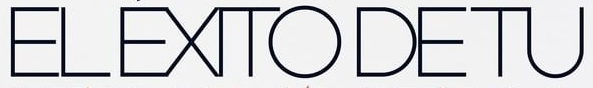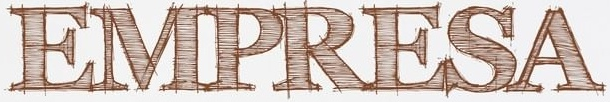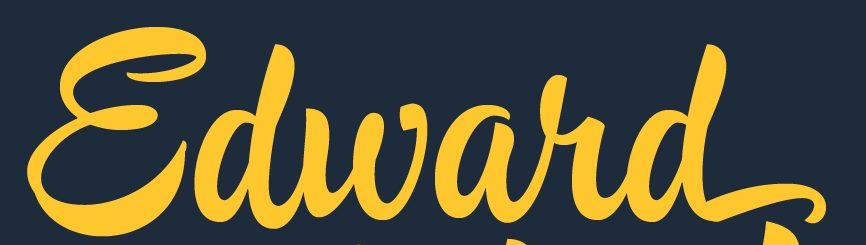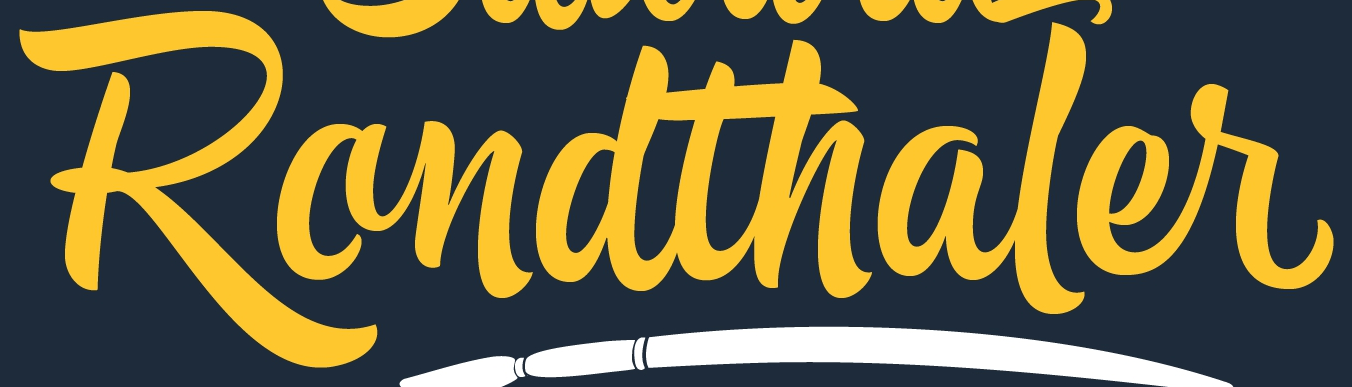What words are shown in these images in order, separated by a semicolon? ELÉXITODETU; EMPRESA; Edward; Randthaler 